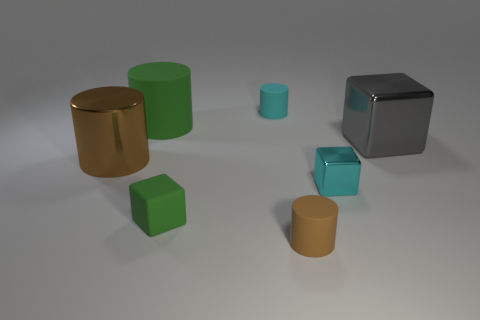Which object stands out the most and why? The cyan cube with a reflective surface stands out due to its bright color and polished surface, which contrasts with the matte textures of the other objects. What does the reflection on the cyan cube tell us about the environment? The reflection on the cyan cube indicates that the environment is brightly lit, with light coming from above, creating soft shadows on the ground. It suggests a simple, uncluttered space. 